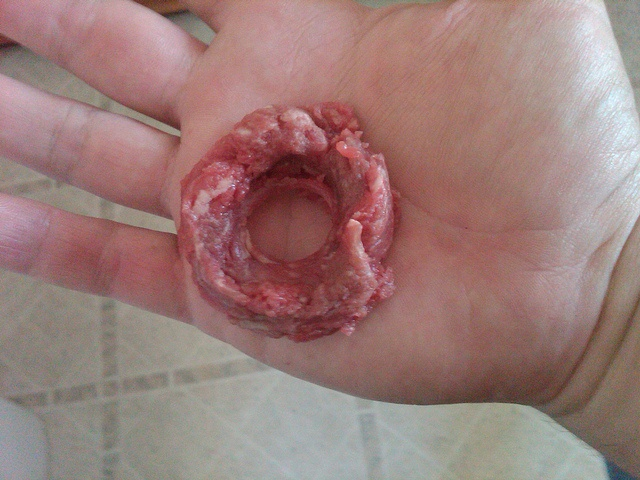Describe the objects in this image and their specific colors. I can see people in brown, salmon, darkgray, and gray tones and donut in salmon, brown, and maroon tones in this image. 